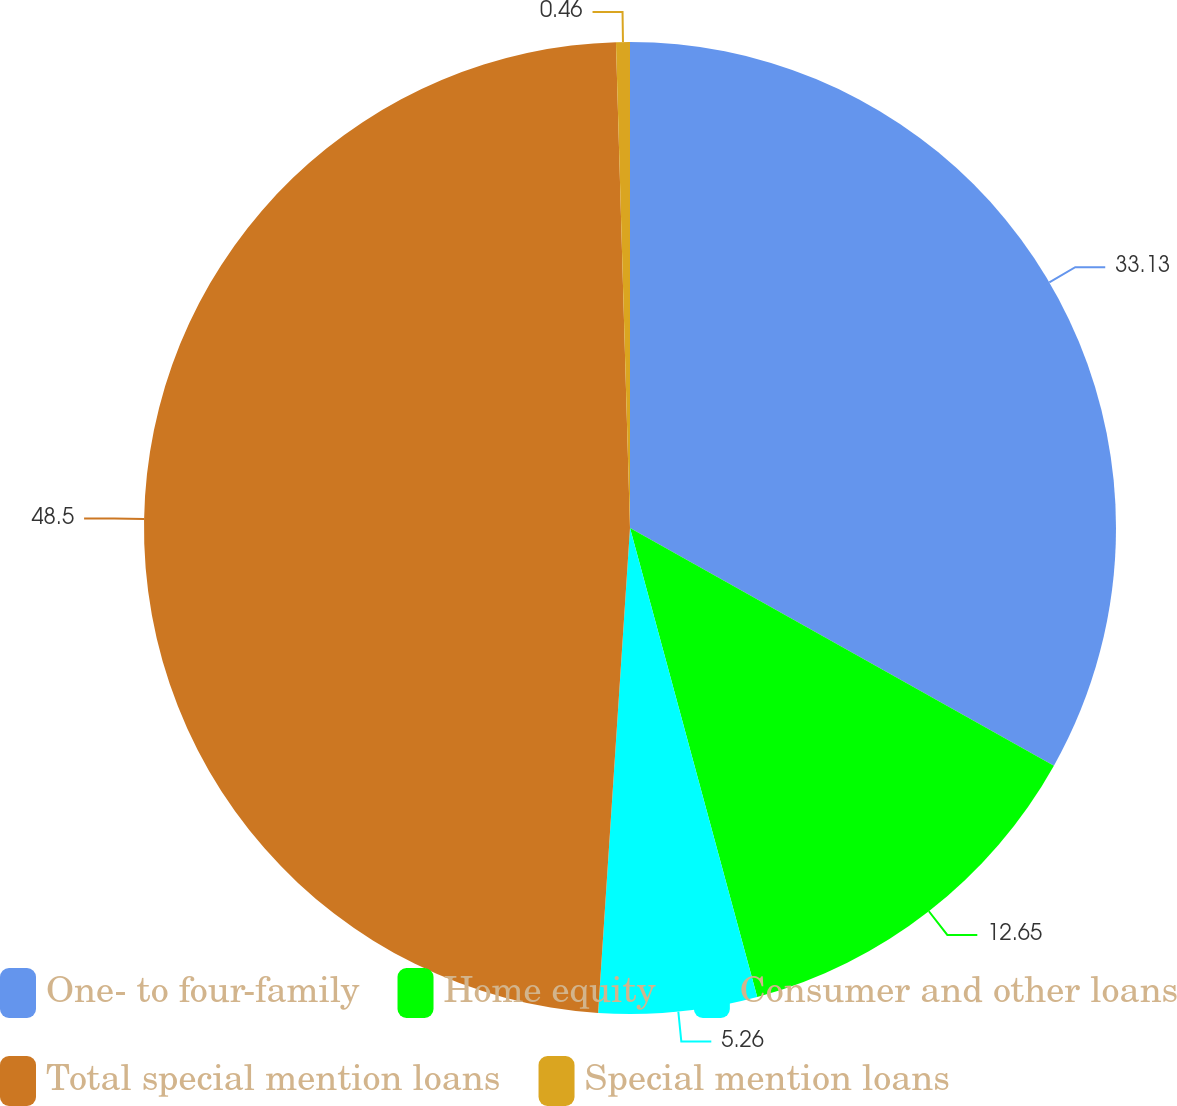Convert chart. <chart><loc_0><loc_0><loc_500><loc_500><pie_chart><fcel>One- to four-family<fcel>Home equity<fcel>Consumer and other loans<fcel>Total special mention loans<fcel>Special mention loans<nl><fcel>33.13%<fcel>12.65%<fcel>5.26%<fcel>48.49%<fcel>0.46%<nl></chart> 